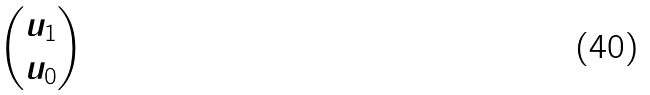<formula> <loc_0><loc_0><loc_500><loc_500>\begin{pmatrix} u _ { 1 } \\ u _ { 0 } \end{pmatrix}</formula> 